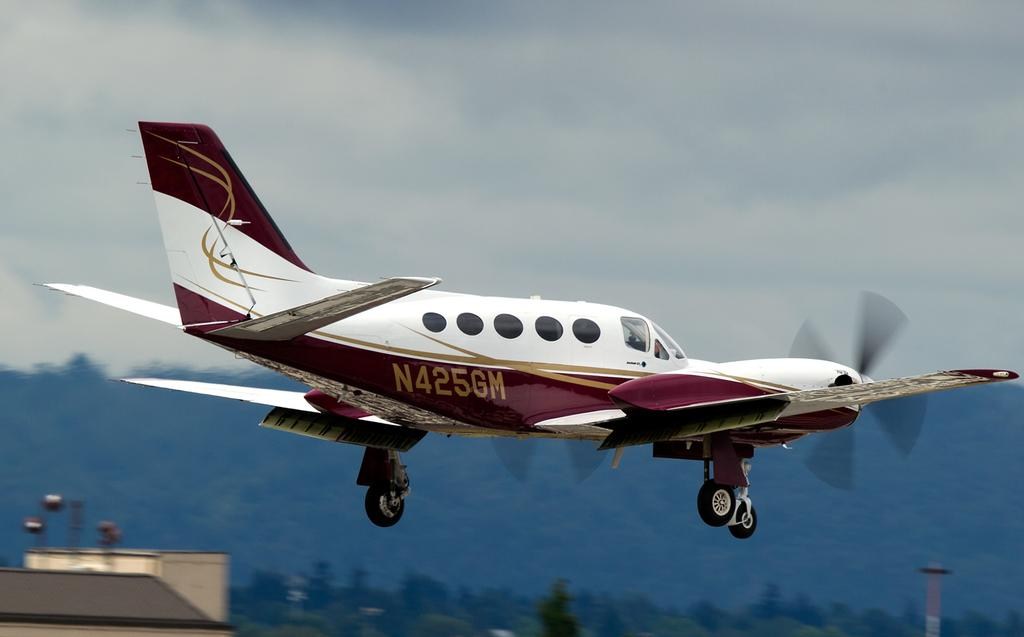What is the main subject of the image? There is an aeroplane flying in the image. What can be seen in the background of the image? Hills and the sky are visible in the background of the image. What type of vegetation is at the bottom of the image? There are trees at the bottom of the image. What object is also present at the bottom of the image? There is a pole at the bottom of the image. How many spiders are crawling on the aeroplane in the image? There are no spiders present in the image; it features an aeroplane flying in the sky. What type of knot is used to secure the pole at the bottom of the image? There is no knot visible in the image, as it only shows an aeroplane, hills, the sky, trees, and a pole. 